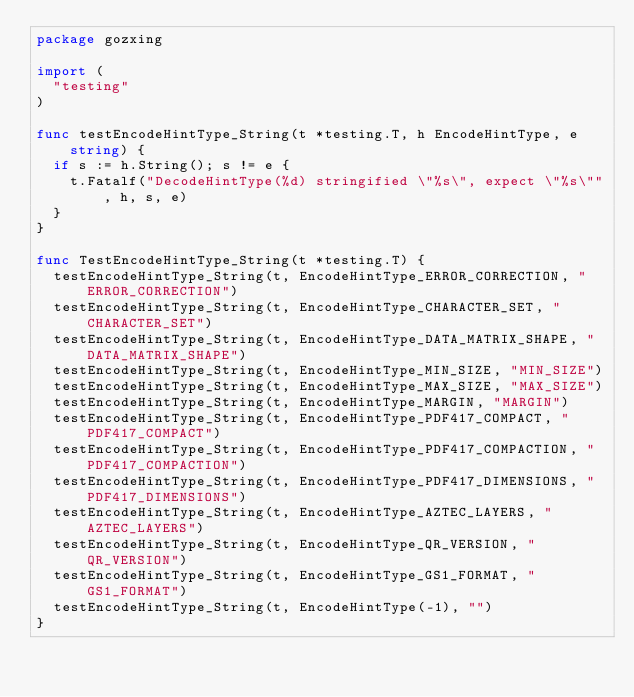<code> <loc_0><loc_0><loc_500><loc_500><_Go_>package gozxing

import (
	"testing"
)

func testEncodeHintType_String(t *testing.T, h EncodeHintType, e string) {
	if s := h.String(); s != e {
		t.Fatalf("DecodeHintType(%d) stringified \"%s\", expect \"%s\"", h, s, e)
	}
}

func TestEncodeHintType_String(t *testing.T) {
	testEncodeHintType_String(t, EncodeHintType_ERROR_CORRECTION, "ERROR_CORRECTION")
	testEncodeHintType_String(t, EncodeHintType_CHARACTER_SET, "CHARACTER_SET")
	testEncodeHintType_String(t, EncodeHintType_DATA_MATRIX_SHAPE, "DATA_MATRIX_SHAPE")
	testEncodeHintType_String(t, EncodeHintType_MIN_SIZE, "MIN_SIZE")
	testEncodeHintType_String(t, EncodeHintType_MAX_SIZE, "MAX_SIZE")
	testEncodeHintType_String(t, EncodeHintType_MARGIN, "MARGIN")
	testEncodeHintType_String(t, EncodeHintType_PDF417_COMPACT, "PDF417_COMPACT")
	testEncodeHintType_String(t, EncodeHintType_PDF417_COMPACTION, "PDF417_COMPACTION")
	testEncodeHintType_String(t, EncodeHintType_PDF417_DIMENSIONS, "PDF417_DIMENSIONS")
	testEncodeHintType_String(t, EncodeHintType_AZTEC_LAYERS, "AZTEC_LAYERS")
	testEncodeHintType_String(t, EncodeHintType_QR_VERSION, "QR_VERSION")
	testEncodeHintType_String(t, EncodeHintType_GS1_FORMAT, "GS1_FORMAT")
	testEncodeHintType_String(t, EncodeHintType(-1), "")
}
</code> 